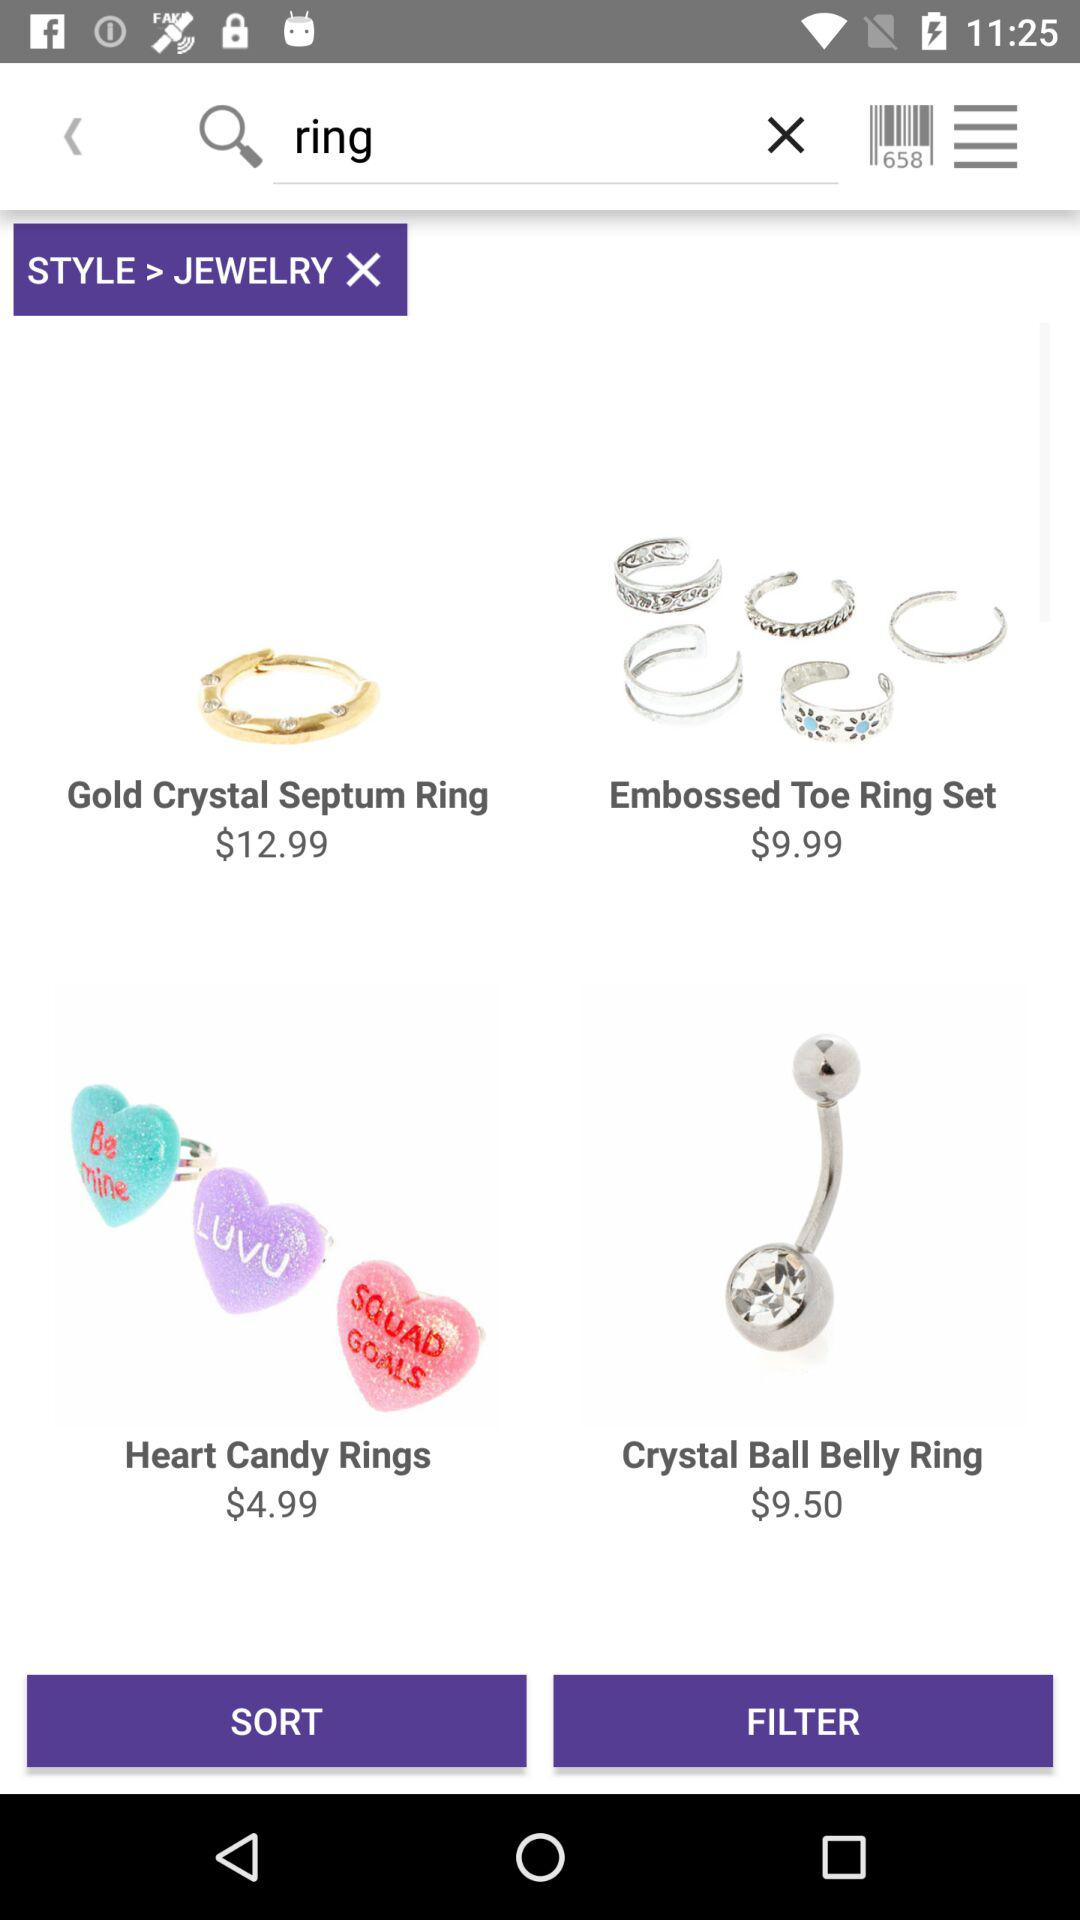Which item has a price of $9.99? The item that has a price of $9.99 is the "Embossed Toe Ring Set". 